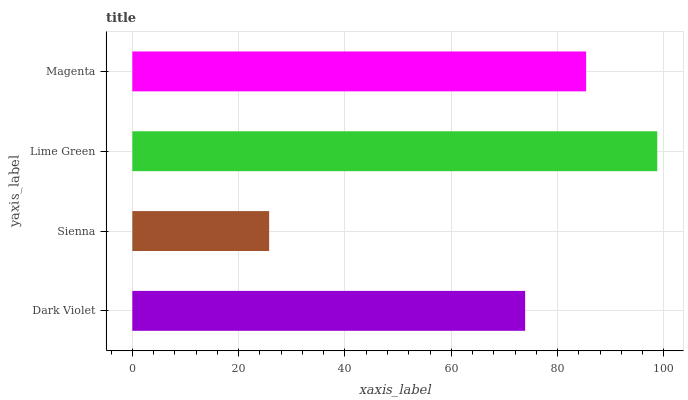Is Sienna the minimum?
Answer yes or no. Yes. Is Lime Green the maximum?
Answer yes or no. Yes. Is Lime Green the minimum?
Answer yes or no. No. Is Sienna the maximum?
Answer yes or no. No. Is Lime Green greater than Sienna?
Answer yes or no. Yes. Is Sienna less than Lime Green?
Answer yes or no. Yes. Is Sienna greater than Lime Green?
Answer yes or no. No. Is Lime Green less than Sienna?
Answer yes or no. No. Is Magenta the high median?
Answer yes or no. Yes. Is Dark Violet the low median?
Answer yes or no. Yes. Is Sienna the high median?
Answer yes or no. No. Is Magenta the low median?
Answer yes or no. No. 